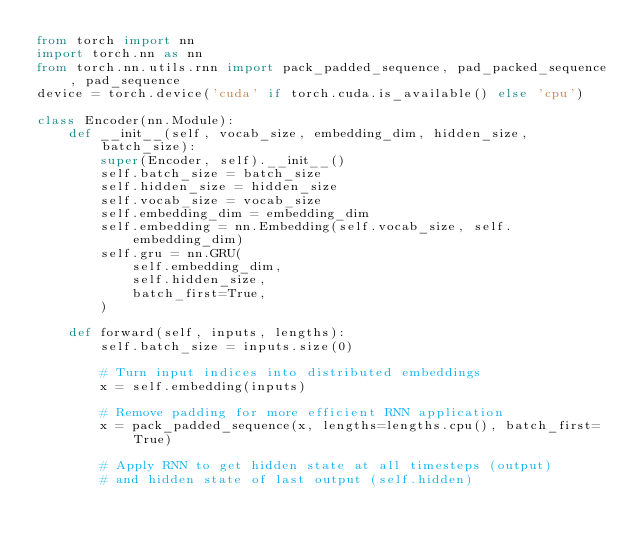Convert code to text. <code><loc_0><loc_0><loc_500><loc_500><_Python_>from torch import nn
import torch.nn as nn
from torch.nn.utils.rnn import pack_padded_sequence, pad_packed_sequence, pad_sequence
device = torch.device('cuda' if torch.cuda.is_available() else 'cpu')

class Encoder(nn.Module):
    def __init__(self, vocab_size, embedding_dim, hidden_size, batch_size):
        super(Encoder, self).__init__()
        self.batch_size = batch_size
        self.hidden_size = hidden_size
        self.vocab_size = vocab_size
        self.embedding_dim = embedding_dim
        self.embedding = nn.Embedding(self.vocab_size, self.embedding_dim)
        self.gru = nn.GRU(
            self.embedding_dim,
            self.hidden_size,
            batch_first=True,
        )
        
    def forward(self, inputs, lengths):
        self.batch_size = inputs.size(0)
        
        # Turn input indices into distributed embeddings
        x = self.embedding(inputs)

        # Remove padding for more efficient RNN application
        x = pack_padded_sequence(x, lengths=lengths.cpu(), batch_first=True)
    
        # Apply RNN to get hidden state at all timesteps (output)
        # and hidden state of last output (self.hidden)</code> 